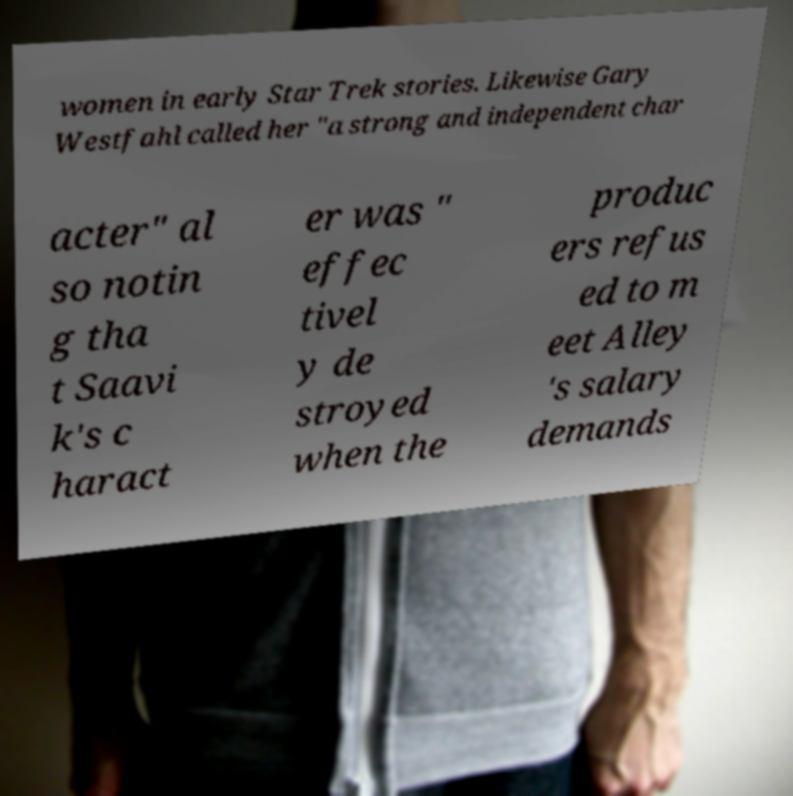For documentation purposes, I need the text within this image transcribed. Could you provide that? women in early Star Trek stories. Likewise Gary Westfahl called her "a strong and independent char acter" al so notin g tha t Saavi k's c haract er was " effec tivel y de stroyed when the produc ers refus ed to m eet Alley 's salary demands 